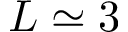Convert formula to latex. <formula><loc_0><loc_0><loc_500><loc_500>L \simeq 3</formula> 